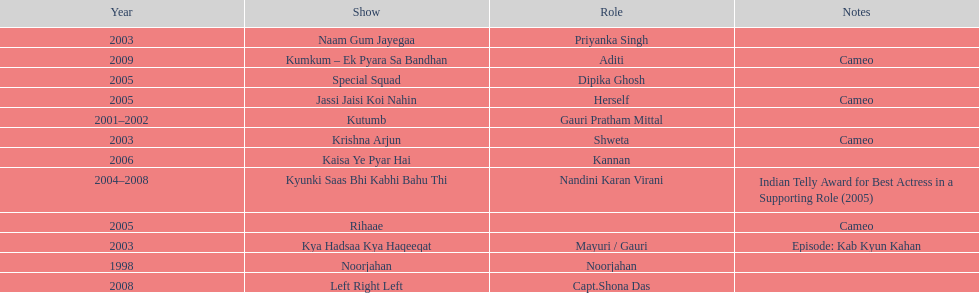How many shows were there in 2005? 3. 